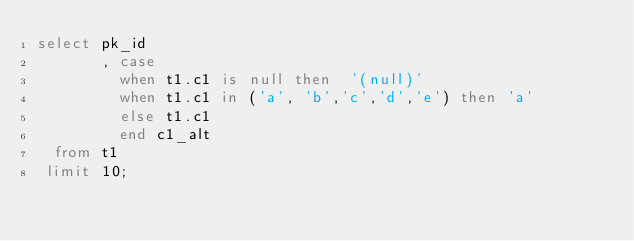Convert code to text. <code><loc_0><loc_0><loc_500><loc_500><_SQL_>select pk_id
       , case
         when t1.c1 is null then  '(null)'
         when t1.c1 in ('a', 'b','c','d','e') then 'a'
         else t1.c1
         end c1_alt
  from t1
 limit 10;
</code> 